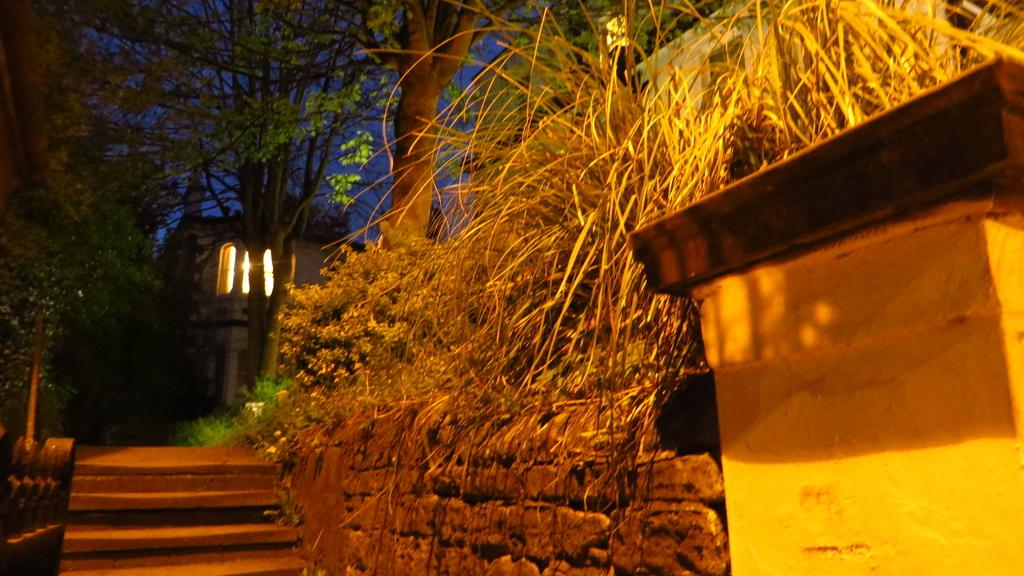What type of structure can be seen in the image? There is a wall in the image. Are there any architectural features associated with the wall? Yes, there are steps on either side of the wall. What can be seen near the steps? There are trees near the steps. What is visible in the background of the image? There is a house in the background of the image. Where is the scarecrow playing volleyball in the image? There is no scarecrow or volleyball present in the image. What type of jewel can be seen on the wall in the image? There is no jewel present on the wall in the image. 